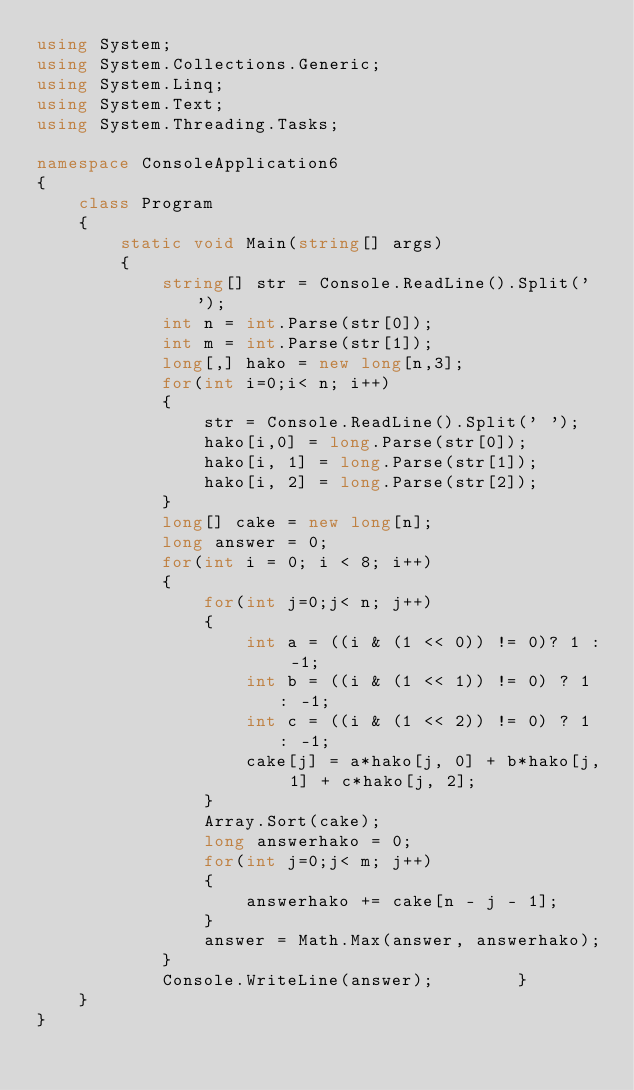<code> <loc_0><loc_0><loc_500><loc_500><_C#_>using System;
using System.Collections.Generic;
using System.Linq;
using System.Text;
using System.Threading.Tasks;

namespace ConsoleApplication6
{
    class Program
    {
        static void Main(string[] args)
        {
            string[] str = Console.ReadLine().Split(' ');
            int n = int.Parse(str[0]);
            int m = int.Parse(str[1]);
            long[,] hako = new long[n,3];
            for(int i=0;i< n; i++)
            {
                str = Console.ReadLine().Split(' ');
                hako[i,0] = long.Parse(str[0]);
                hako[i, 1] = long.Parse(str[1]);
                hako[i, 2] = long.Parse(str[2]);
            }
            long[] cake = new long[n];
            long answer = 0;
            for(int i = 0; i < 8; i++)
            {
                for(int j=0;j< n; j++)
                {
                    int a = ((i & (1 << 0)) != 0)? 1 : -1;
                    int b = ((i & (1 << 1)) != 0) ? 1 : -1;
                    int c = ((i & (1 << 2)) != 0) ? 1 : -1;
                    cake[j] = a*hako[j, 0] + b*hako[j, 1] + c*hako[j, 2];
                }
                Array.Sort(cake);
                long answerhako = 0;
                for(int j=0;j< m; j++)
                {
                    answerhako += cake[n - j - 1];
                }
                answer = Math.Max(answer, answerhako);
            }
            Console.WriteLine(answer);        }
    }
}</code> 